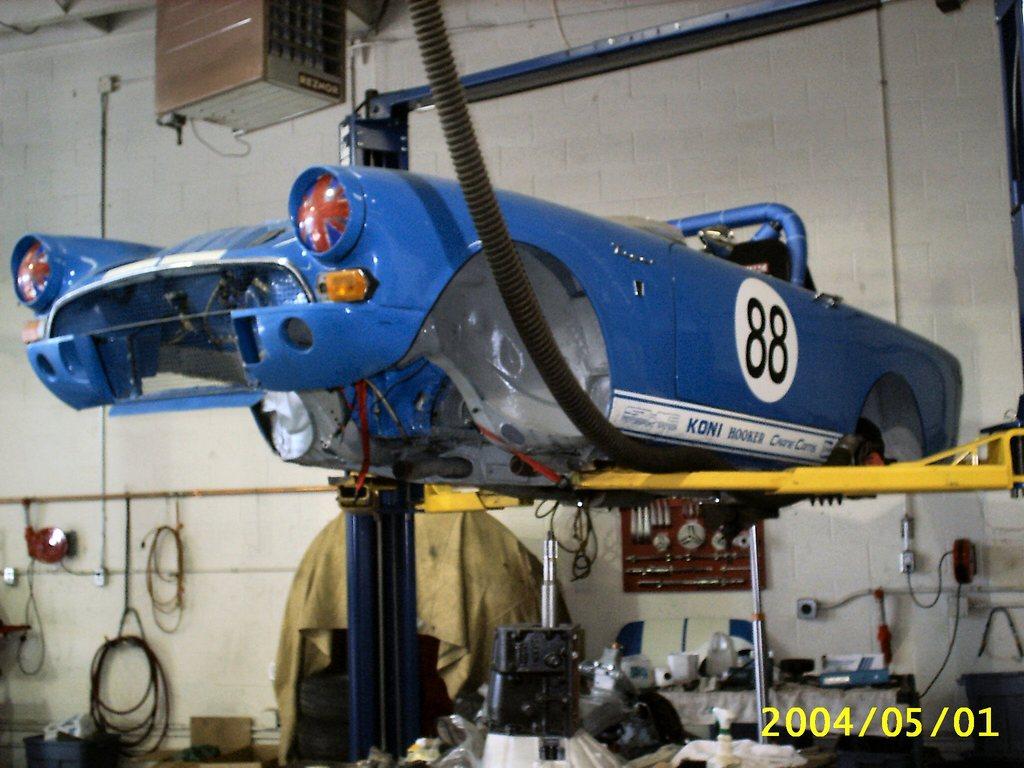What is written beside the word koni on the bottom of the door under 88?
Your answer should be compact. Hooker. What is this cars racing number?
Provide a succinct answer. 88. 